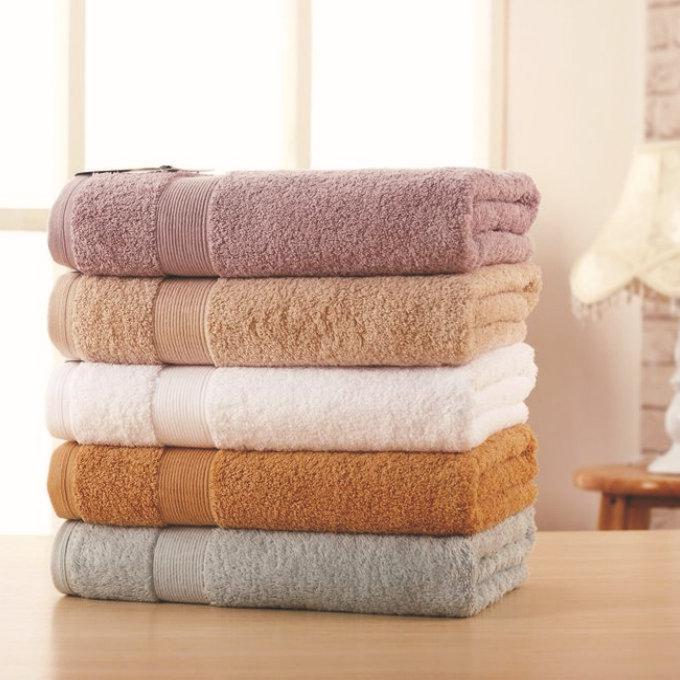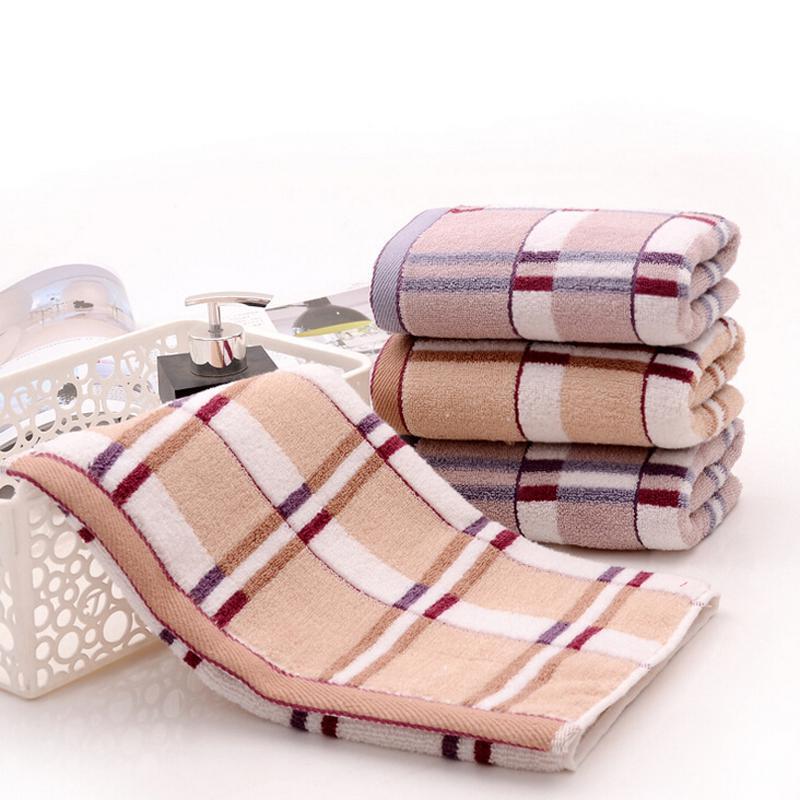The first image is the image on the left, the second image is the image on the right. Analyze the images presented: Is the assertion "There is a towel draped over a basket in one of the images." valid? Answer yes or no. Yes. 